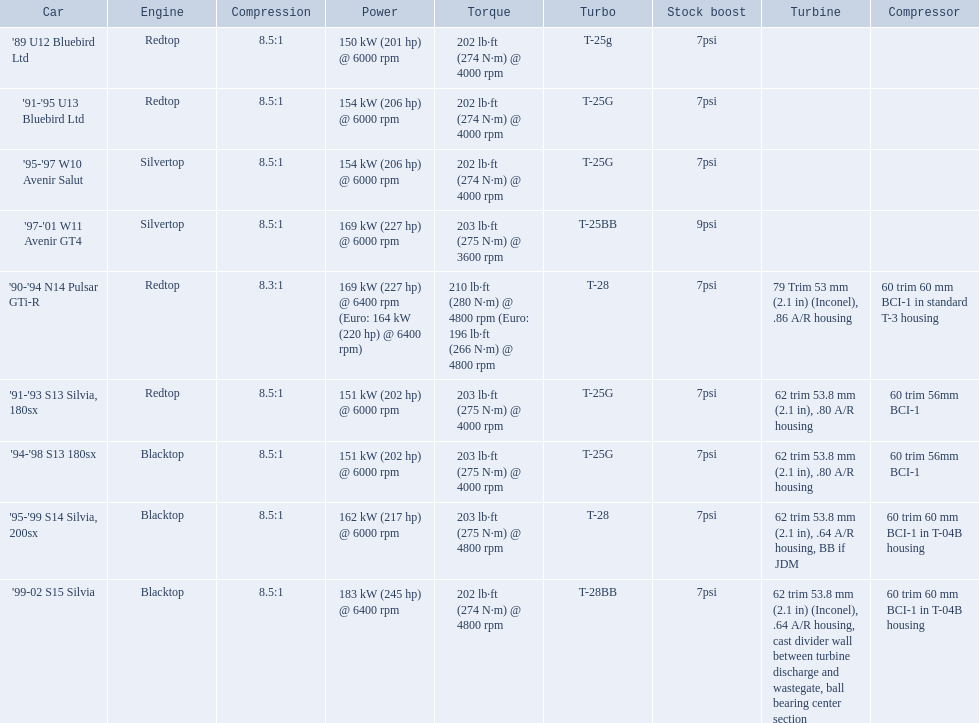What are the indicated horsepower for each car? 150 kW (201 hp) @ 6000 rpm, 154 kW (206 hp) @ 6000 rpm, 154 kW (206 hp) @ 6000 rpm, 169 kW (227 hp) @ 6000 rpm, 169 kW (227 hp) @ 6400 rpm (Euro: 164 kW (220 hp) @ 6400 rpm), 151 kW (202 hp) @ 6000 rpm, 151 kW (202 hp) @ 6000 rpm, 162 kW (217 hp) @ 6000 rpm, 183 kW (245 hp) @ 6400 rpm. Which vehicle has the unique feature of having above 230 hp? '99-02 S15 Silvia. 